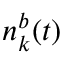<formula> <loc_0><loc_0><loc_500><loc_500>n _ { k } ^ { b } ( t )</formula> 